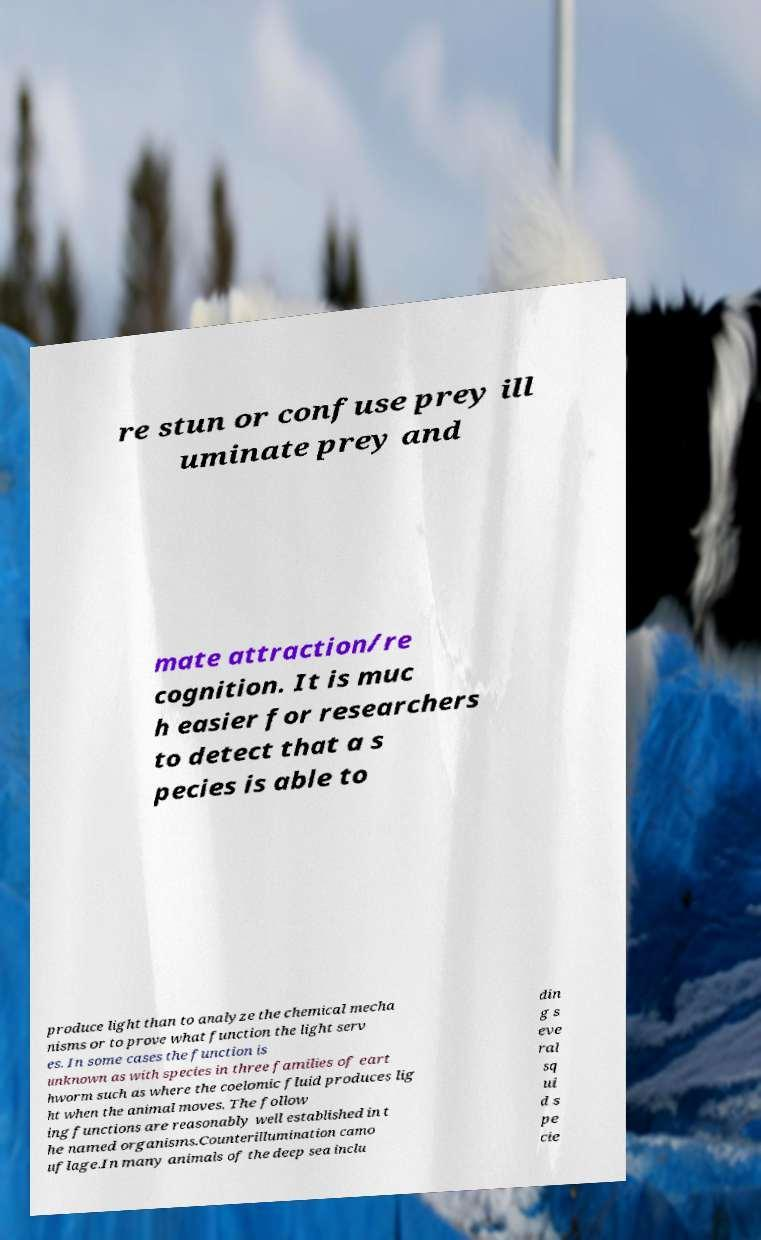Could you assist in decoding the text presented in this image and type it out clearly? re stun or confuse prey ill uminate prey and mate attraction/re cognition. It is muc h easier for researchers to detect that a s pecies is able to produce light than to analyze the chemical mecha nisms or to prove what function the light serv es. In some cases the function is unknown as with species in three families of eart hworm such as where the coelomic fluid produces lig ht when the animal moves. The follow ing functions are reasonably well established in t he named organisms.Counterillumination camo uflage.In many animals of the deep sea inclu din g s eve ral sq ui d s pe cie 